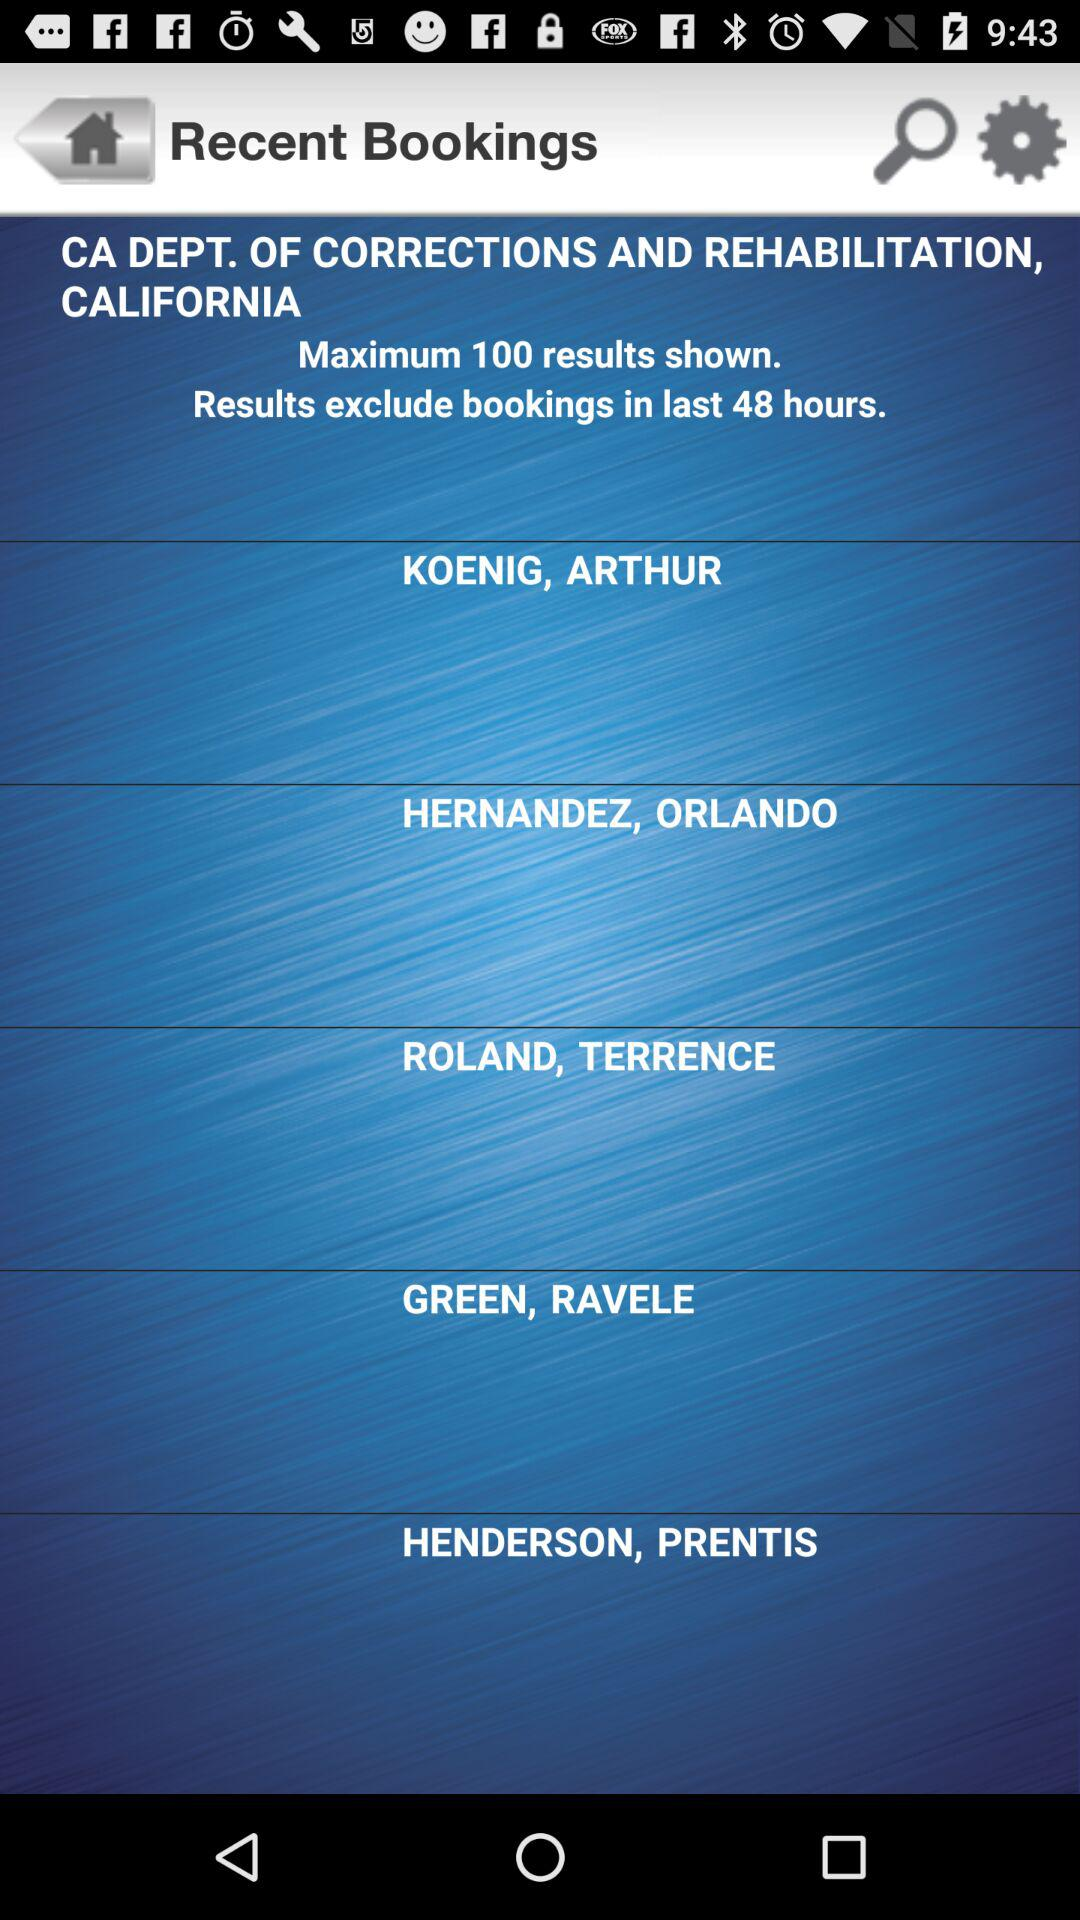What are the maximum numbers for the shown results? The maximum numbers for the shown results are 100. 